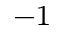Convert formula to latex. <formula><loc_0><loc_0><loc_500><loc_500>^ { - 1 }</formula> 